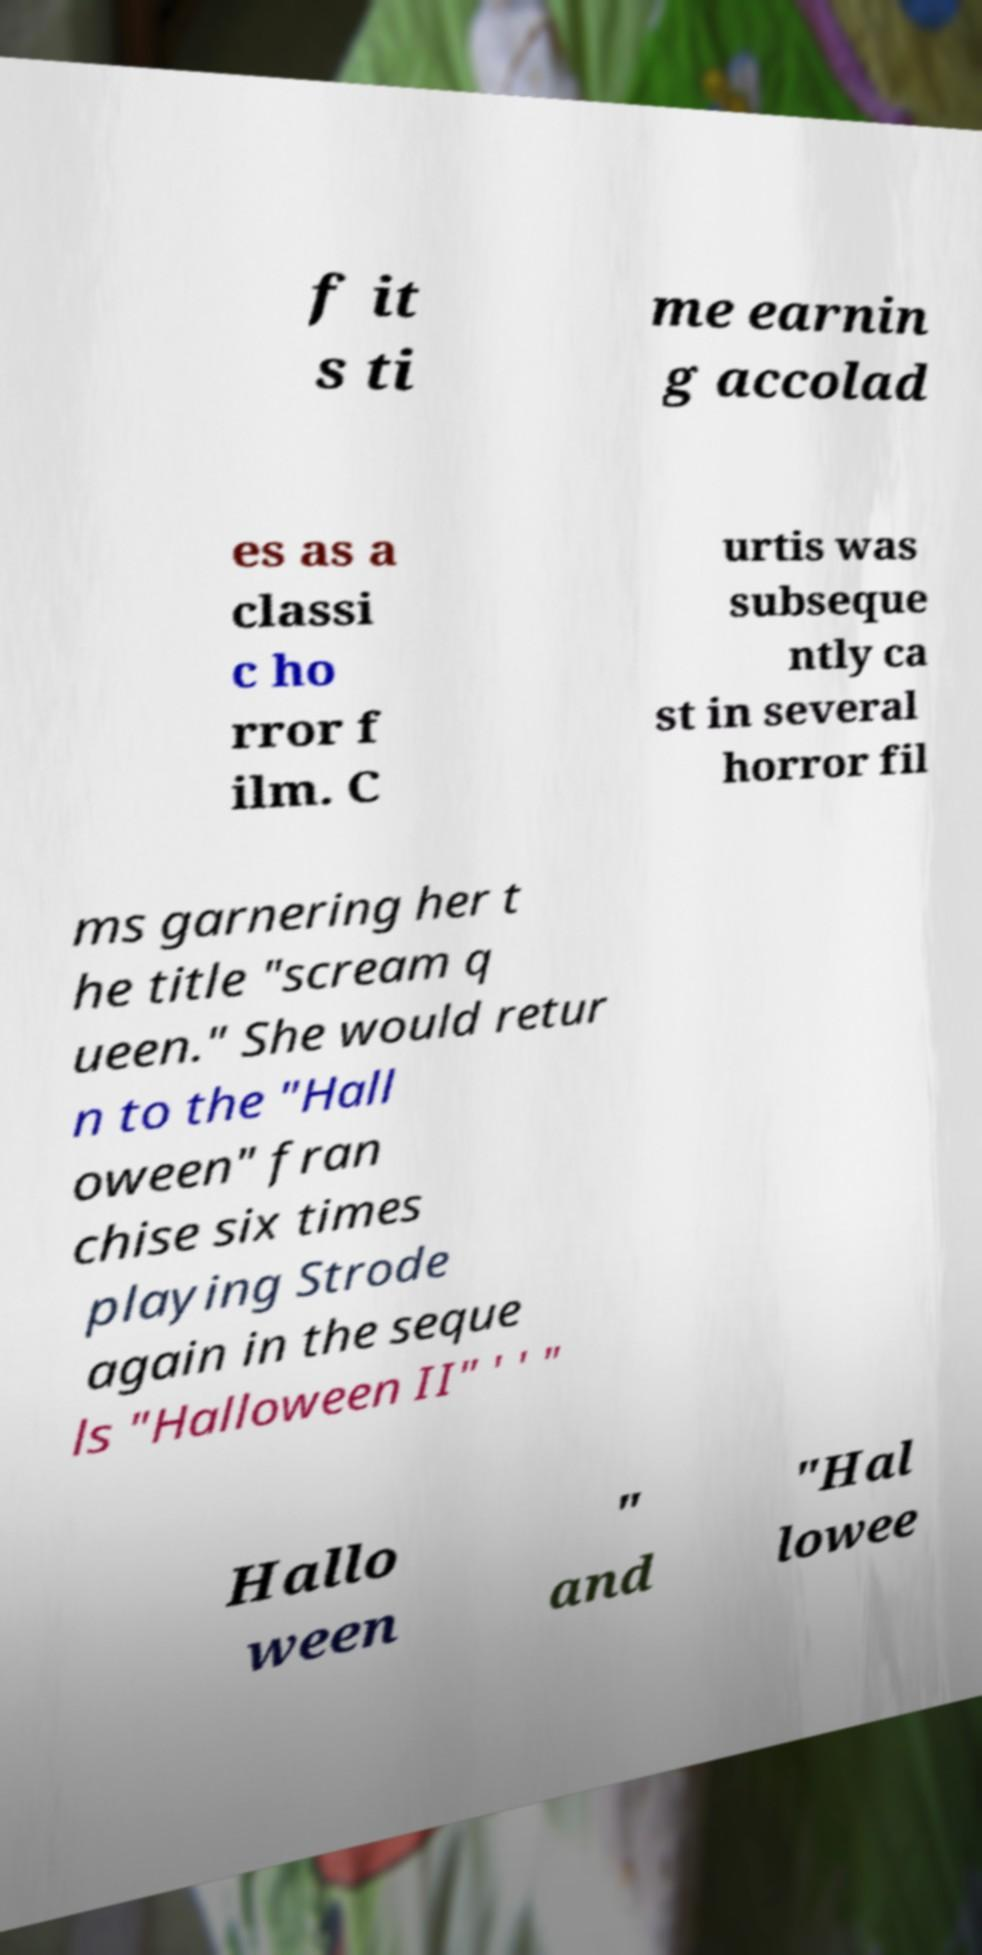For documentation purposes, I need the text within this image transcribed. Could you provide that? f it s ti me earnin g accolad es as a classi c ho rror f ilm. C urtis was subseque ntly ca st in several horror fil ms garnering her t he title "scream q ueen." She would retur n to the "Hall oween" fran chise six times playing Strode again in the seque ls "Halloween II" ' ' " Hallo ween " and "Hal lowee 